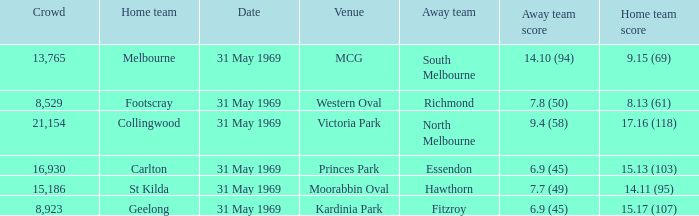What was the largest gathering in victoria park? 21154.0. 